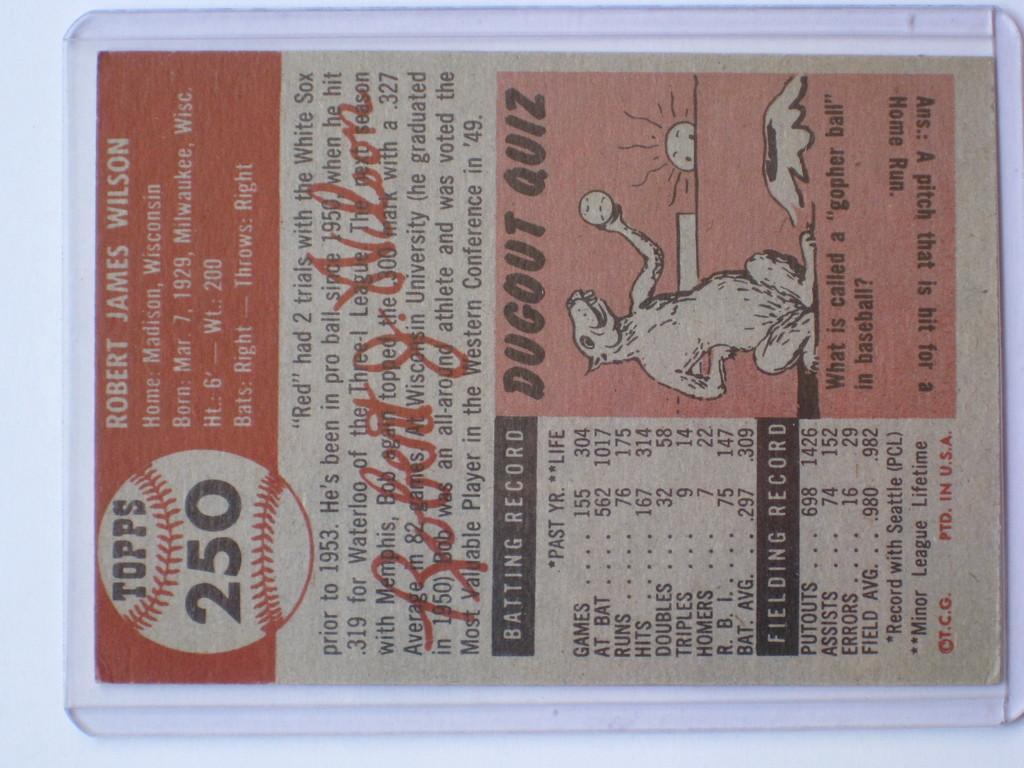Can you describe this image briefly? In the image there is a paper and there is some information mentioned in that paper about a baseball player. 